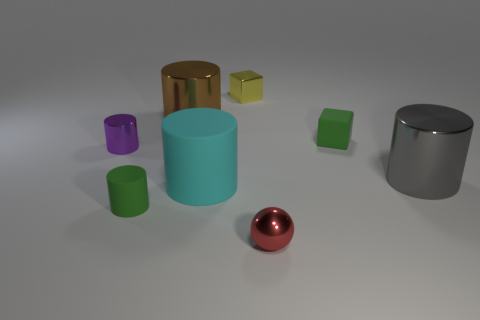Is there any other thing that is the same shape as the red shiny object?
Provide a succinct answer. No. There is a thing that is on the left side of the large brown shiny object and in front of the big cyan rubber cylinder; what shape is it?
Make the answer very short. Cylinder. There is a rubber object that is right of the red thing; what color is it?
Ensure brevity in your answer.  Green. There is a matte object that is behind the green cylinder and in front of the tiny green matte cube; what is its size?
Give a very brief answer. Large. Does the tiny purple cylinder have the same material as the small cylinder in front of the big gray metallic cylinder?
Provide a succinct answer. No. What number of cyan matte objects are the same shape as the large gray metal object?
Make the answer very short. 1. There is a small cube that is the same color as the tiny rubber cylinder; what is its material?
Provide a succinct answer. Rubber. How many tiny purple metal cylinders are there?
Provide a short and direct response. 1. There is a yellow metal thing; is its shape the same as the small shiny object that is in front of the small purple metal cylinder?
Provide a succinct answer. No. How many objects are either metallic cubes or large things in front of the tiny green block?
Provide a succinct answer. 3. 